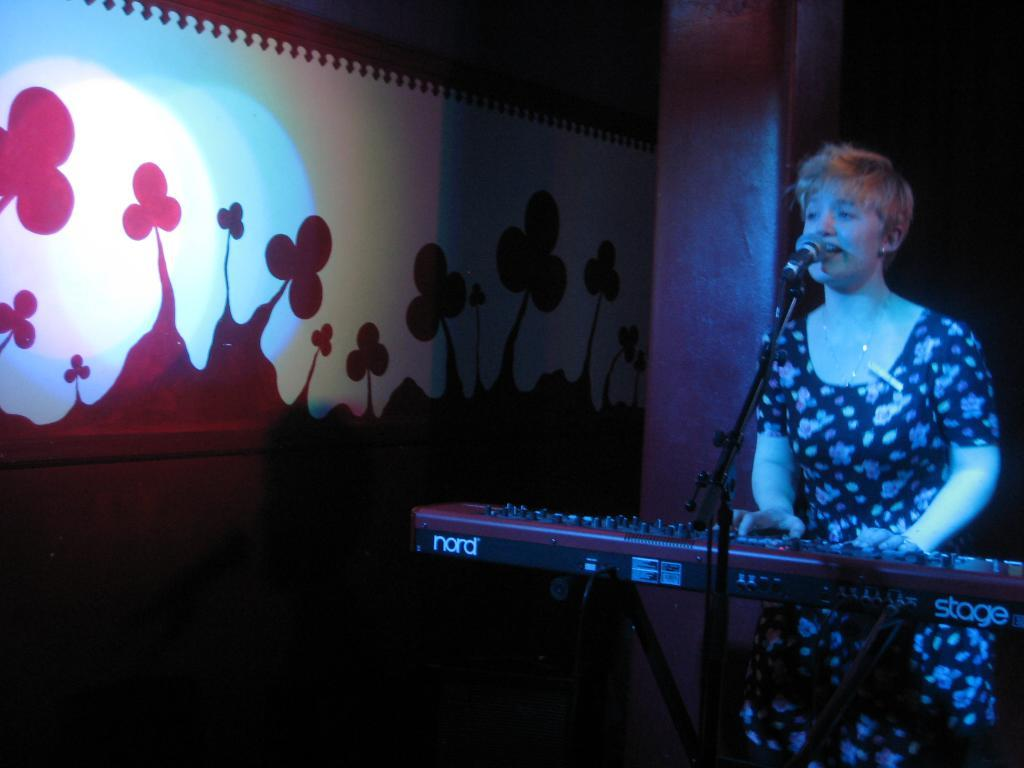Who is the main subject in the image? There is a woman in the image. What is the woman doing in the image? The woman is standing and playing the piano. What is in front of the woman? There is a microphone stand in front of the woman. What can be seen on the left side of the image? There is a wall with a painting on the left side of the image. What type of religious ceremony is taking place in the image? There is no indication of a religious ceremony in the image; it features a woman playing the piano with a microphone stand in front of her and a painting on the wall. Can you tell me how many ants are crawling on the piano keys? There are no ants present in the image; it only shows a woman playing the piano, a microphone stand, and a painting on the wall. 